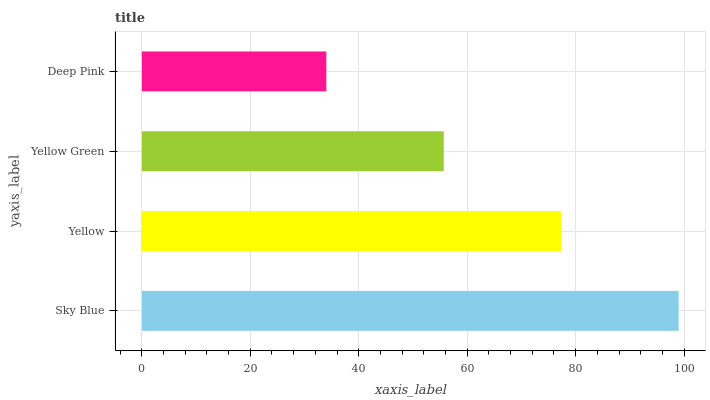Is Deep Pink the minimum?
Answer yes or no. Yes. Is Sky Blue the maximum?
Answer yes or no. Yes. Is Yellow the minimum?
Answer yes or no. No. Is Yellow the maximum?
Answer yes or no. No. Is Sky Blue greater than Yellow?
Answer yes or no. Yes. Is Yellow less than Sky Blue?
Answer yes or no. Yes. Is Yellow greater than Sky Blue?
Answer yes or no. No. Is Sky Blue less than Yellow?
Answer yes or no. No. Is Yellow the high median?
Answer yes or no. Yes. Is Yellow Green the low median?
Answer yes or no. Yes. Is Deep Pink the high median?
Answer yes or no. No. Is Yellow the low median?
Answer yes or no. No. 